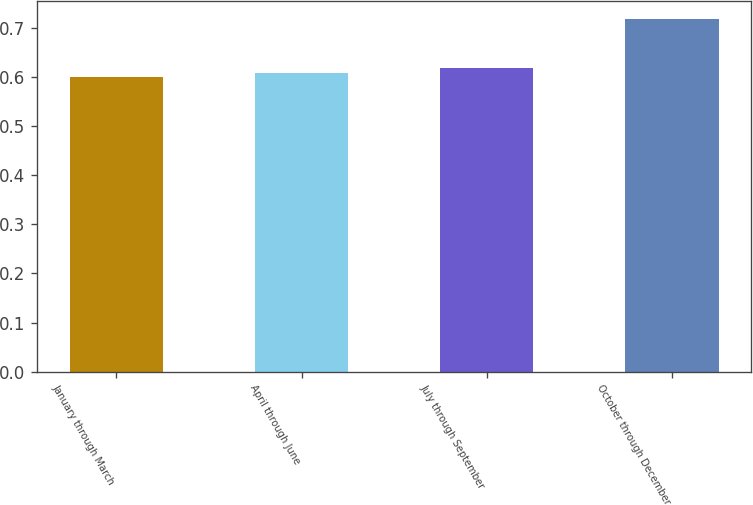Convert chart. <chart><loc_0><loc_0><loc_500><loc_500><bar_chart><fcel>January through March<fcel>April through June<fcel>July through September<fcel>October through December<nl><fcel>0.6<fcel>0.61<fcel>0.62<fcel>0.72<nl></chart> 